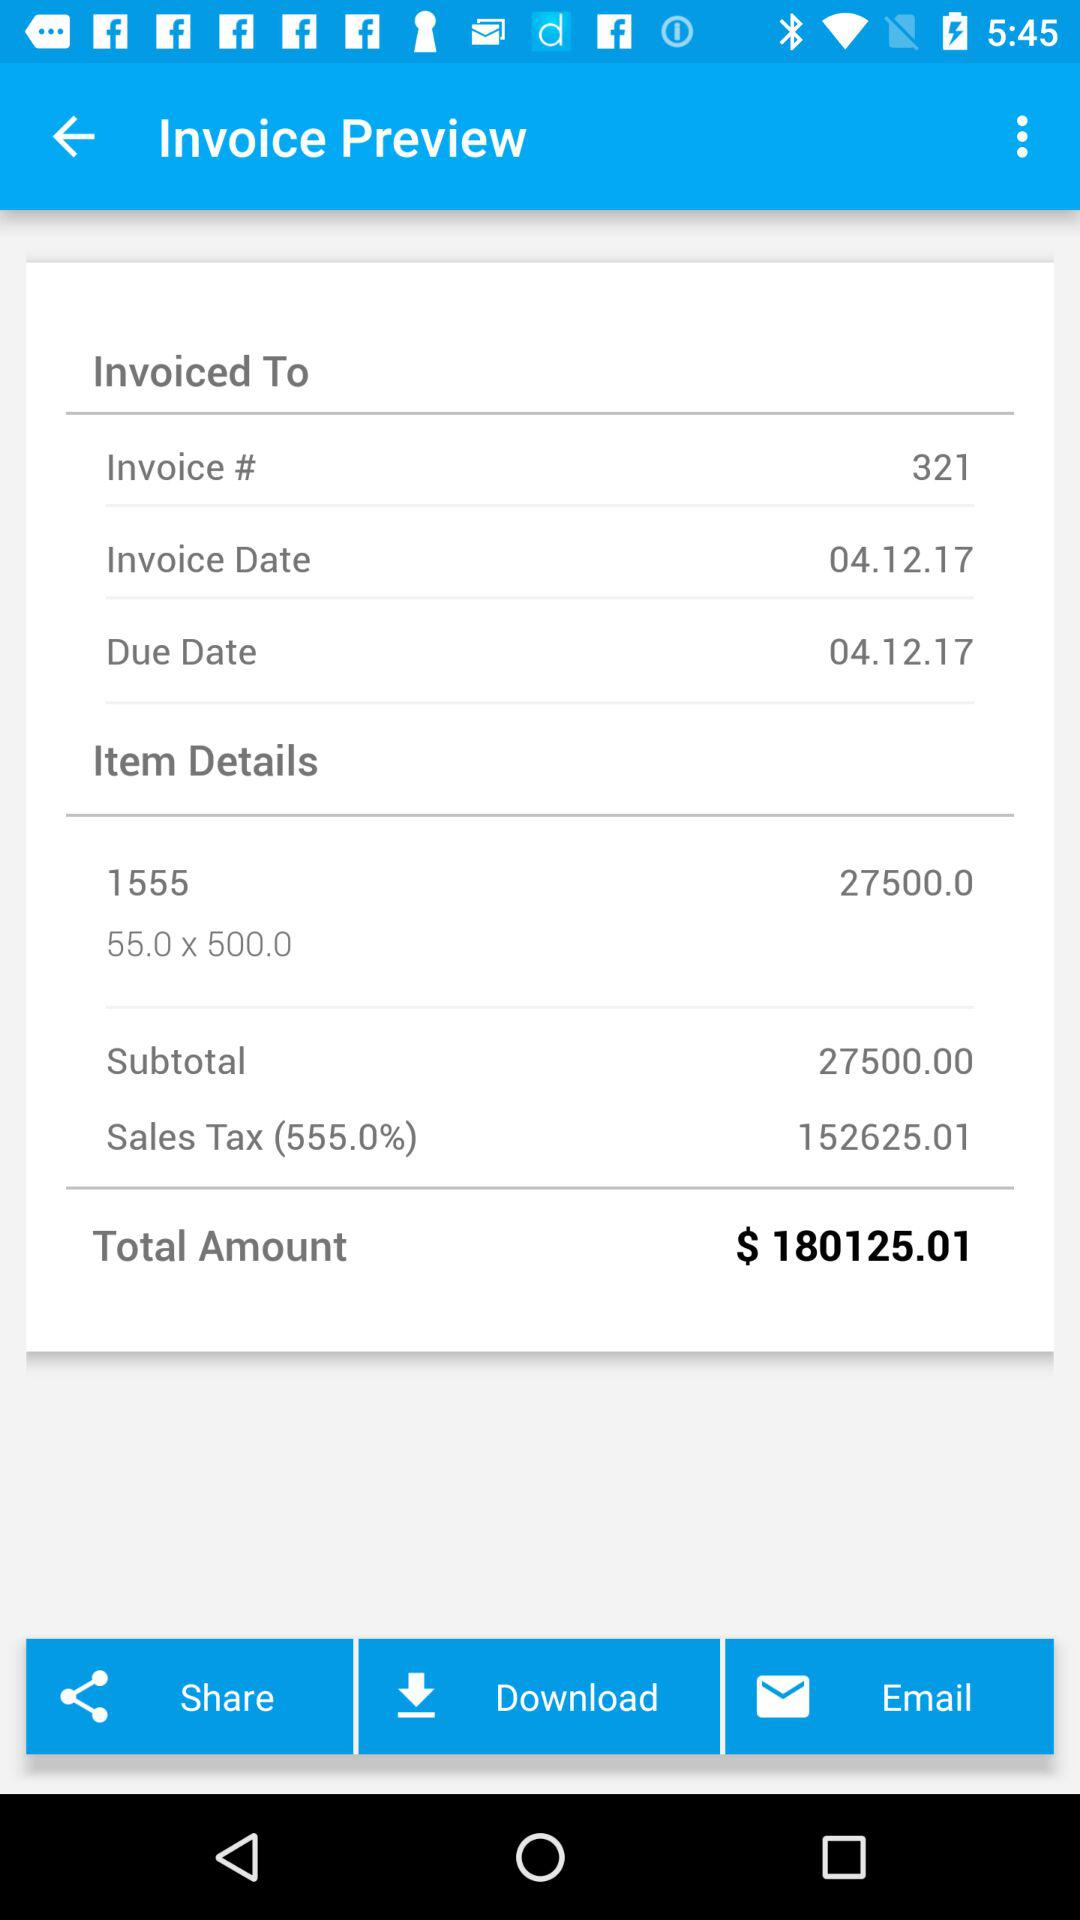What is the total amount due on this invoice?
Answer the question using a single word or phrase. $ 180125.01 